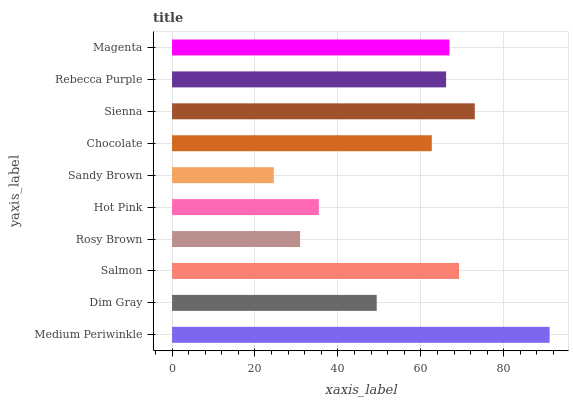Is Sandy Brown the minimum?
Answer yes or no. Yes. Is Medium Periwinkle the maximum?
Answer yes or no. Yes. Is Dim Gray the minimum?
Answer yes or no. No. Is Dim Gray the maximum?
Answer yes or no. No. Is Medium Periwinkle greater than Dim Gray?
Answer yes or no. Yes. Is Dim Gray less than Medium Periwinkle?
Answer yes or no. Yes. Is Dim Gray greater than Medium Periwinkle?
Answer yes or no. No. Is Medium Periwinkle less than Dim Gray?
Answer yes or no. No. Is Rebecca Purple the high median?
Answer yes or no. Yes. Is Chocolate the low median?
Answer yes or no. Yes. Is Sienna the high median?
Answer yes or no. No. Is Magenta the low median?
Answer yes or no. No. 